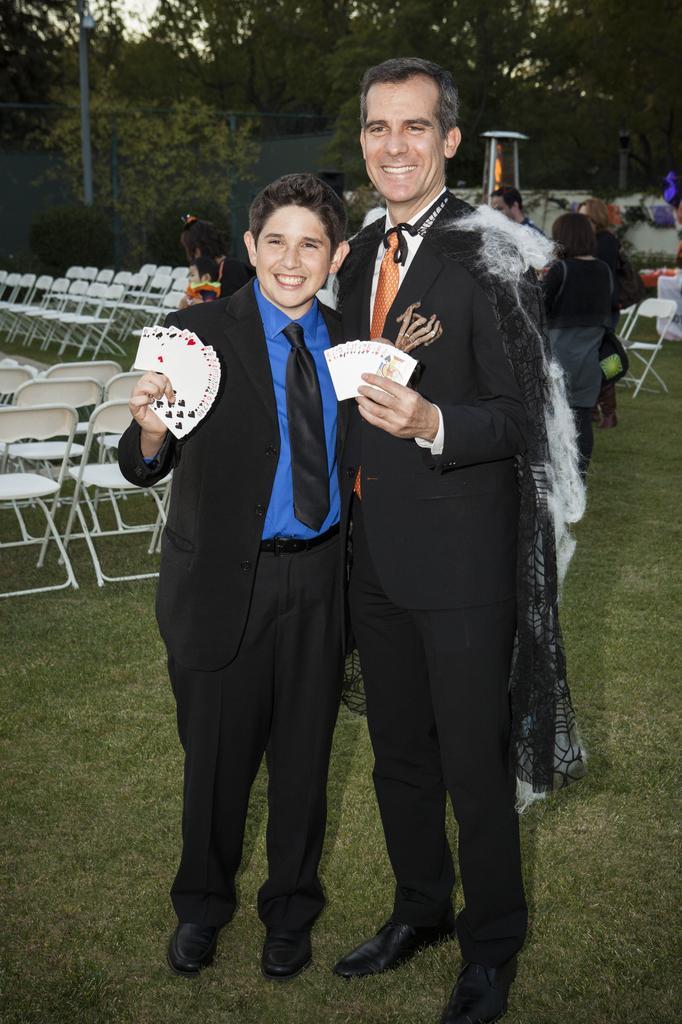Please provide a concise description of this image. In this picture we can see two men are standing and holding playing cards, at the bottom there is grass, on the left side we can see chairs, in the background there are some people standing, we can also see some trees and a pole in the background, there is the sky at the top of the picture. 